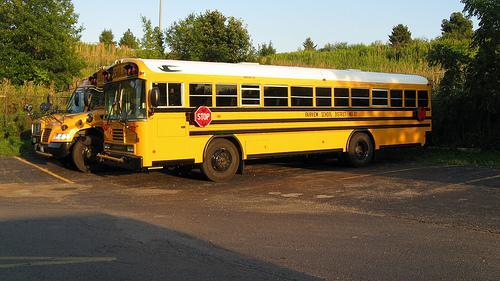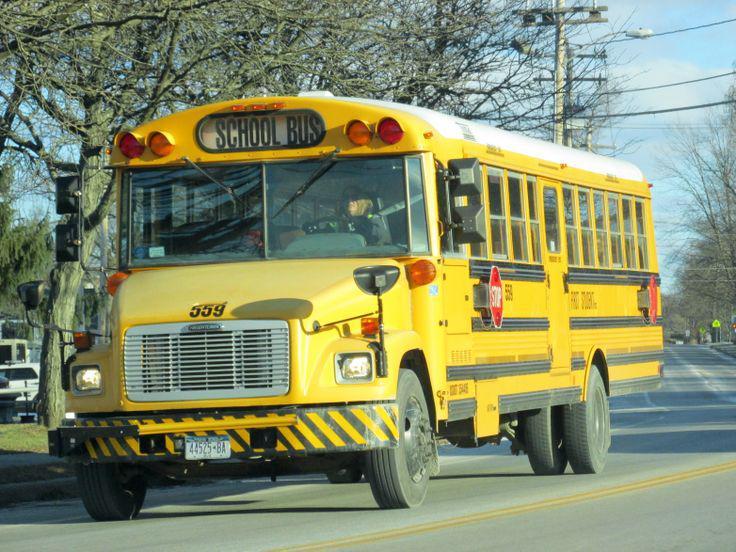The first image is the image on the left, the second image is the image on the right. Assess this claim about the two images: "The front of the buses in both pictures are facing the left of the picture.". Correct or not? Answer yes or no. Yes. The first image is the image on the left, the second image is the image on the right. For the images displayed, is the sentence "One of the images shows a school bus with its stop sign extended and the other image shows a school bus without an extended stop sign." factually correct? Answer yes or no. No. 